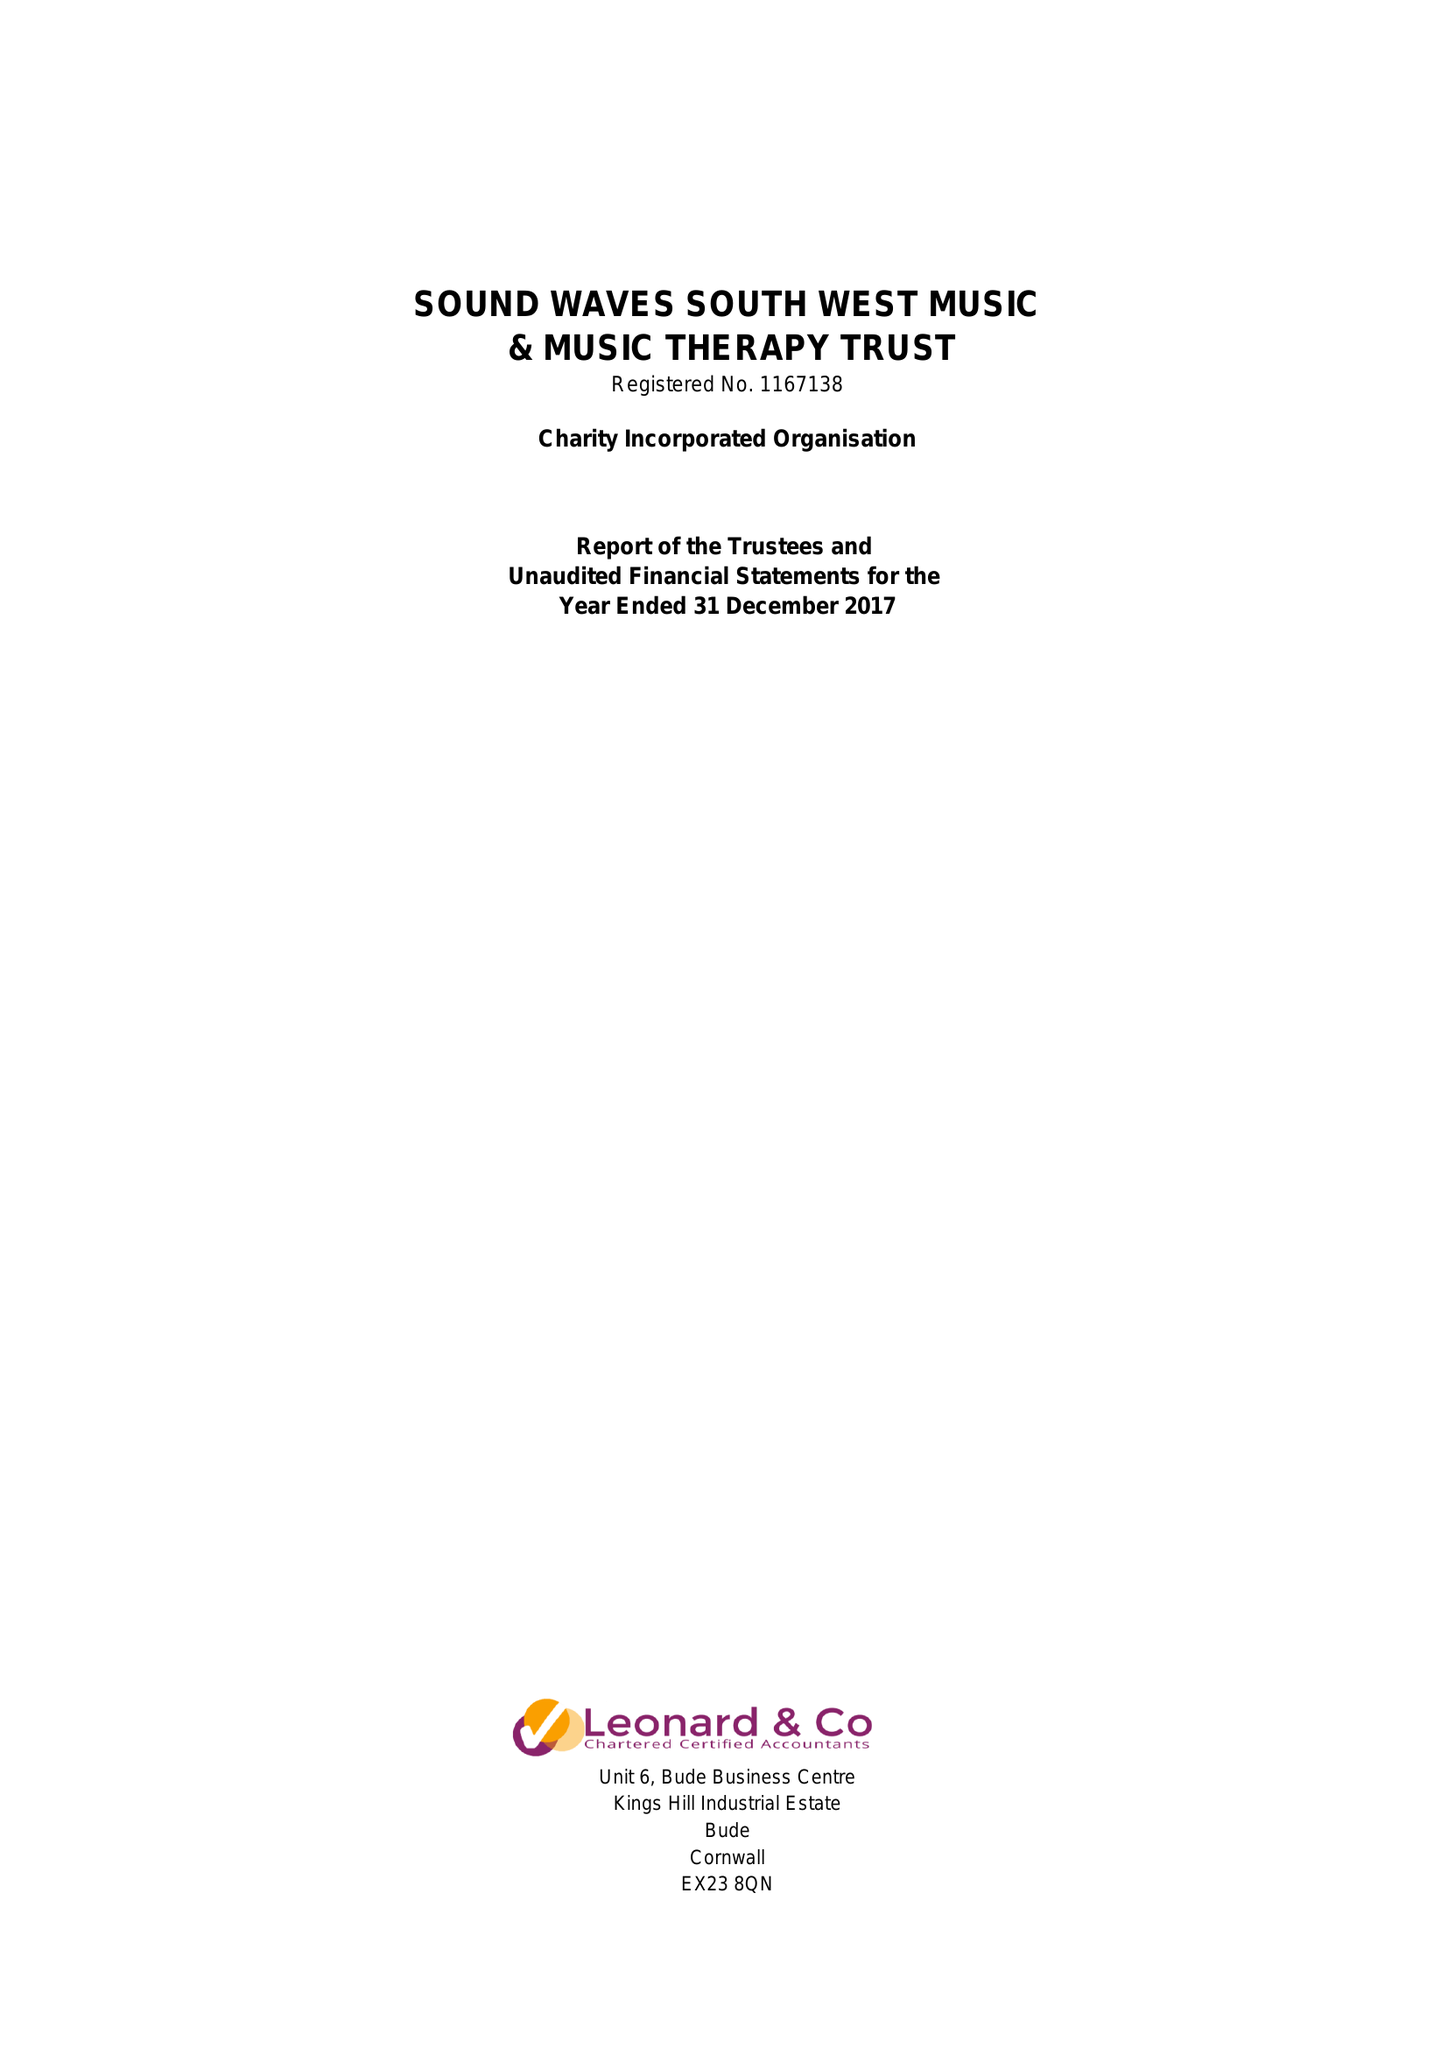What is the value for the report_date?
Answer the question using a single word or phrase. 2017-12-31 